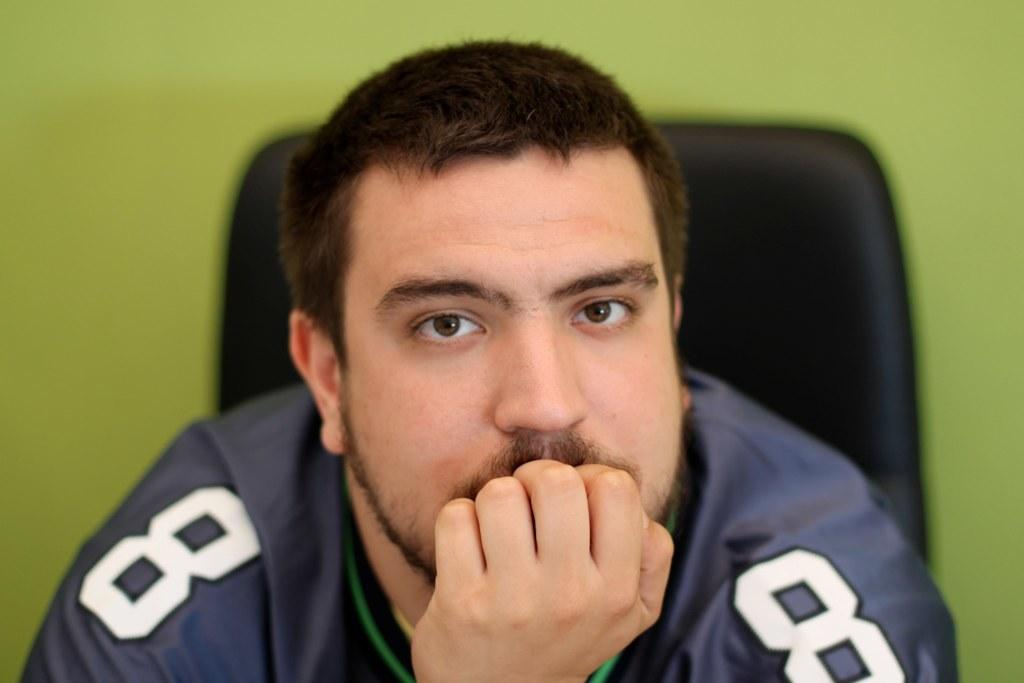Provide a one-sentence caption for the provided image. A man in a blue and green jersey with the number 8 on it. 